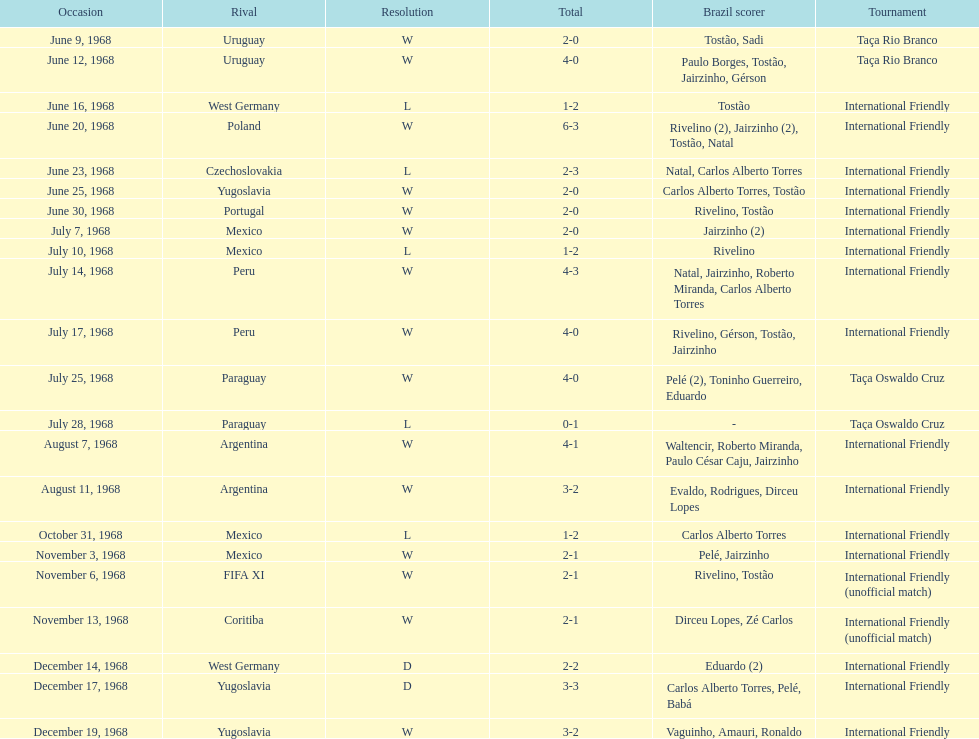What's the total number of ties? 2. 